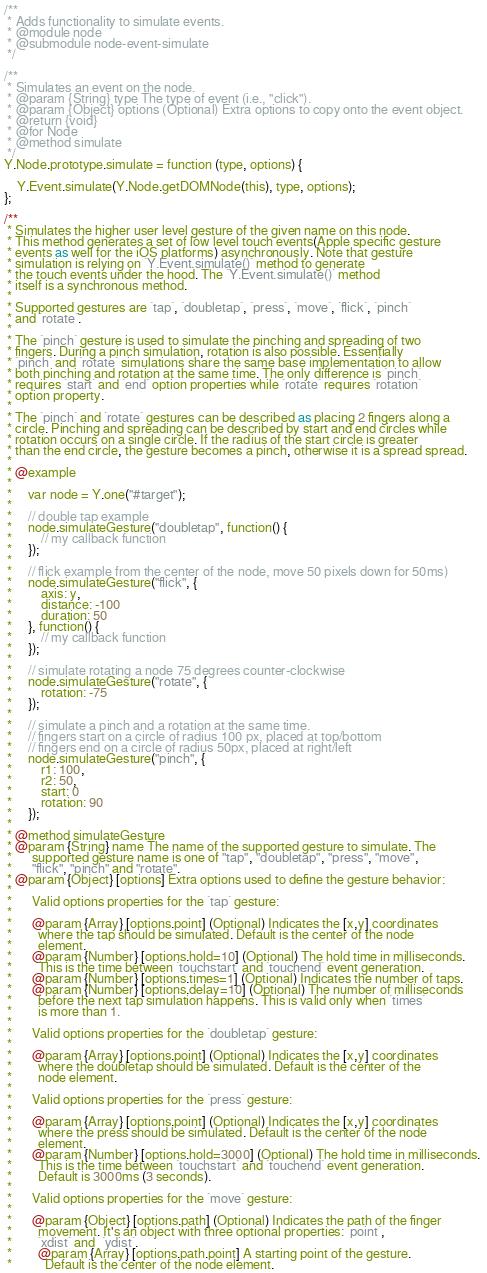<code> <loc_0><loc_0><loc_500><loc_500><_JavaScript_>
/**
 * Adds functionality to simulate events.
 * @module node
 * @submodule node-event-simulate
 */

/**
 * Simulates an event on the node.
 * @param {String} type The type of event (i.e., "click").
 * @param {Object} options (Optional) Extra options to copy onto the event object.
 * @return {void}
 * @for Node
 * @method simulate
 */
Y.Node.prototype.simulate = function (type, options) {
    
    Y.Event.simulate(Y.Node.getDOMNode(this), type, options);
};

/**
 * Simulates the higher user level gesture of the given name on this node. 
 * This method generates a set of low level touch events(Apple specific gesture 
 * events as well for the iOS platforms) asynchronously. Note that gesture  
 * simulation is relying on `Y.Event.simulate()` method to generate 
 * the touch events under the hood. The `Y.Event.simulate()` method
 * itself is a synchronous method.
 * 
 * Supported gestures are `tap`, `doubletap`, `press`, `move`, `flick`, `pinch`
 * and `rotate`.
 * 
 * The `pinch` gesture is used to simulate the pinching and spreading of two
 * fingers. During a pinch simulation, rotation is also possible. Essentially
 * `pinch` and `rotate` simulations share the same base implementation to allow
 * both pinching and rotation at the same time. The only difference is `pinch`
 * requires `start` and `end` option properties while `rotate` requires `rotation` 
 * option property.
 * 
 * The `pinch` and `rotate` gestures can be described as placing 2 fingers along a
 * circle. Pinching and spreading can be described by start and end circles while 
 * rotation occurs on a single circle. If the radius of the start circle is greater 
 * than the end circle, the gesture becomes a pinch, otherwise it is a spread spread.
 * 
 * @example
 *
 *     var node = Y.one("#target");
 *       
 *     // double tap example
 *     node.simulateGesture("doubletap", function() {
 *         // my callback function
 *     });
 *     
 *     // flick example from the center of the node, move 50 pixels down for 50ms)
 *     node.simulateGesture("flick", {
 *         axis: y,
 *         distance: -100
 *         duration: 50
 *     }, function() {
 *         // my callback function
 *     });
 *     
 *     // simulate rotating a node 75 degrees counter-clockwise 
 *     node.simulateGesture("rotate", {
 *         rotation: -75
 *     });
 *
 *     // simulate a pinch and a rotation at the same time. 
 *     // fingers start on a circle of radius 100 px, placed at top/bottom
 *     // fingers end on a circle of radius 50px, placed at right/left 
 *     node.simulateGesture("pinch", {
 *         r1: 100,
 *         r2: 50,
 *         start: 0
 *         rotation: 90
 *     });
 *     
 * @method simulateGesture
 * @param {String} name The name of the supported gesture to simulate. The 
 *      supported gesture name is one of "tap", "doubletap", "press", "move", 
 *      "flick", "pinch" and "rotate". 
 * @param {Object} [options] Extra options used to define the gesture behavior:
 * 
 *      Valid options properties for the `tap` gesture:
 *      
 *      @param {Array} [options.point] (Optional) Indicates the [x,y] coordinates 
 *        where the tap should be simulated. Default is the center of the node 
 *        element.
 *      @param {Number} [options.hold=10] (Optional) The hold time in milliseconds. 
 *        This is the time between `touchstart` and `touchend` event generation.
 *      @param {Number} [options.times=1] (Optional) Indicates the number of taps.
 *      @param {Number} [options.delay=10] (Optional) The number of milliseconds 
 *        before the next tap simulation happens. This is valid only when `times` 
 *        is more than 1. 
 *        
 *      Valid options properties for the `doubletap` gesture:
 *      
 *      @param {Array} [options.point] (Optional) Indicates the [x,y] coordinates 
 *        where the doubletap should be simulated. Default is the center of the 
 *        node element.
 * 
 *      Valid options properties for the `press` gesture:
 *      
 *      @param {Array} [options.point] (Optional) Indicates the [x,y] coordinates 
 *        where the press should be simulated. Default is the center of the node 
 *        element.
 *      @param {Number} [options.hold=3000] (Optional) The hold time in milliseconds. 
 *        This is the time between `touchstart` and `touchend` event generation. 
 *        Default is 3000ms (3 seconds).
 * 
 *      Valid options properties for the `move` gesture:
 *      
 *      @param {Object} [options.path] (Optional) Indicates the path of the finger 
 *        movement. It's an object with three optional properties: `point`, 
 *        `xdist` and  `ydist`.
 *        @param {Array} [options.path.point] A starting point of the gesture.
 *          Default is the center of the node element.</code> 